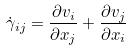Convert formula to latex. <formula><loc_0><loc_0><loc_500><loc_500>\dot { \gamma } _ { i j } = \frac { \partial v _ { i } } { \partial x _ { j } } + \frac { \partial v _ { j } } { \partial x _ { i } }</formula> 